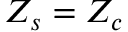Convert formula to latex. <formula><loc_0><loc_0><loc_500><loc_500>Z _ { s } = Z _ { c }</formula> 